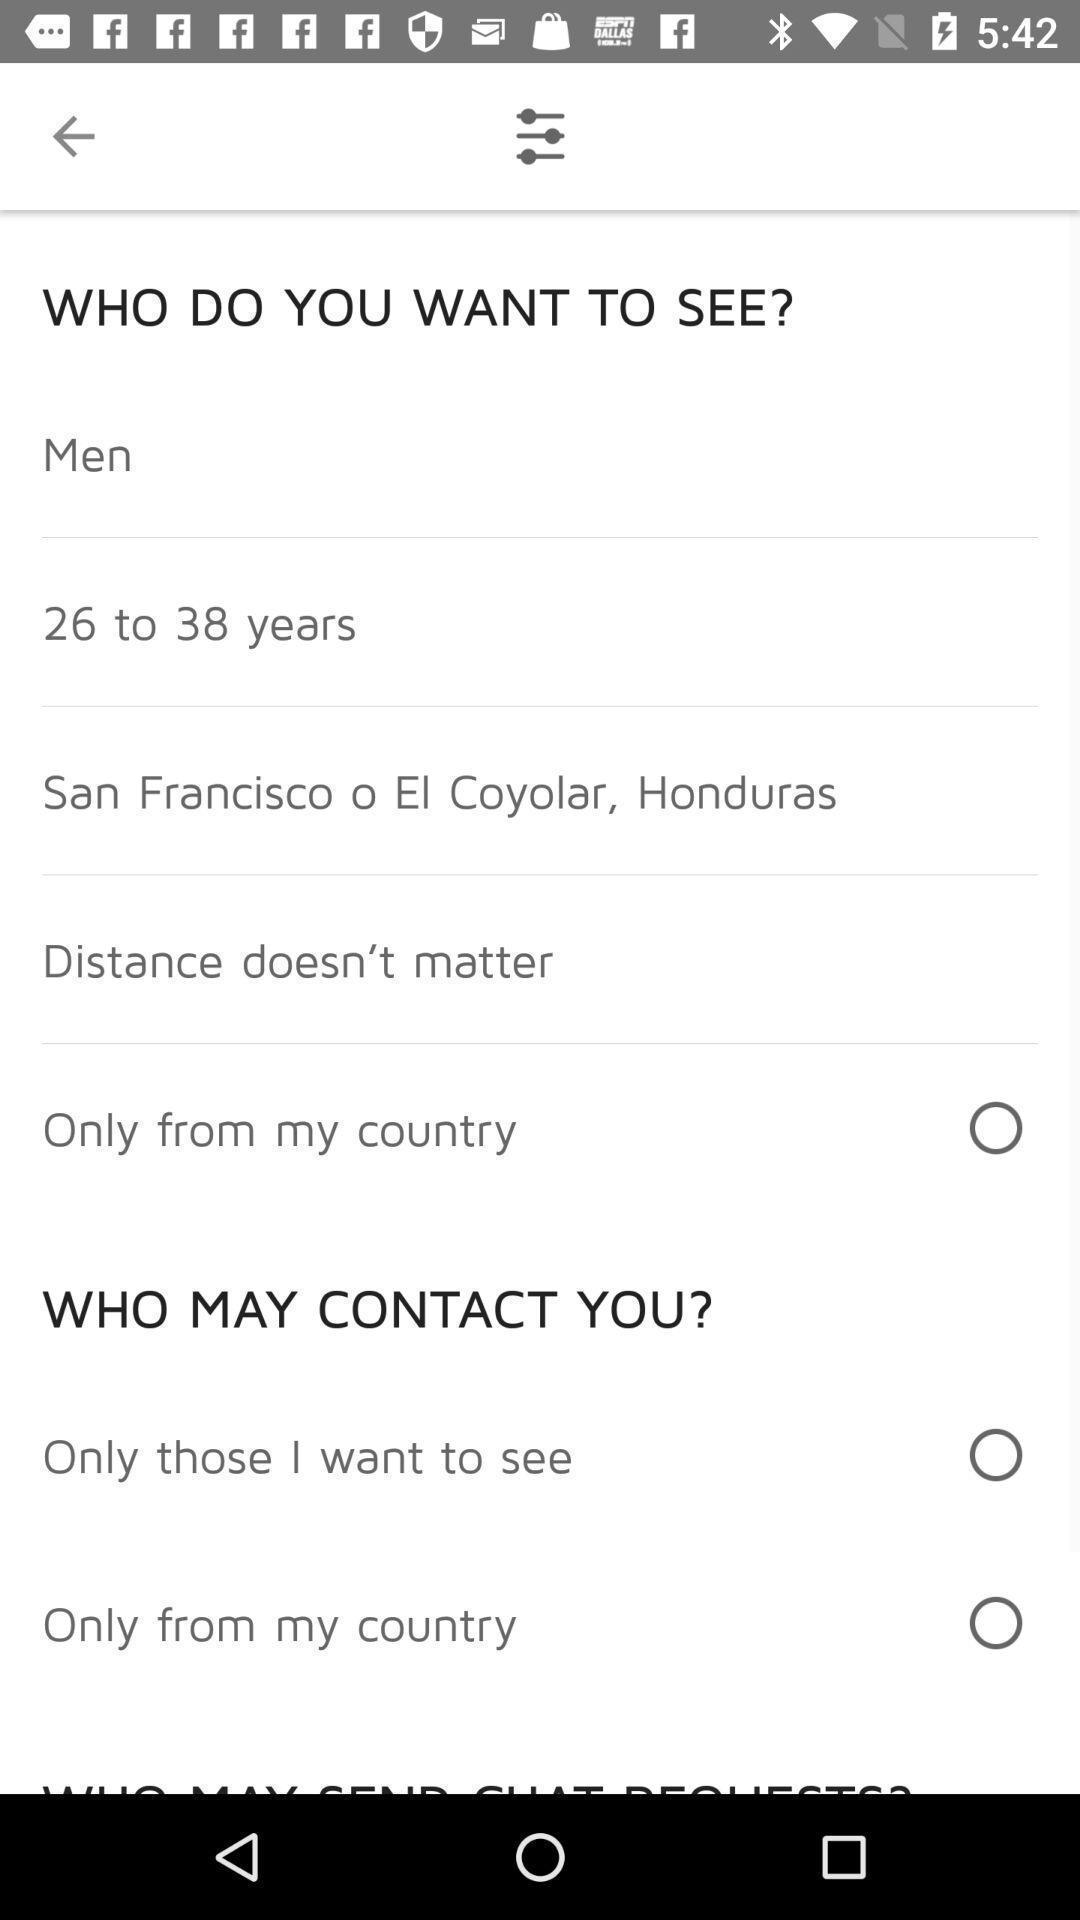Tell me what you see in this picture. Screen shows list of options. 